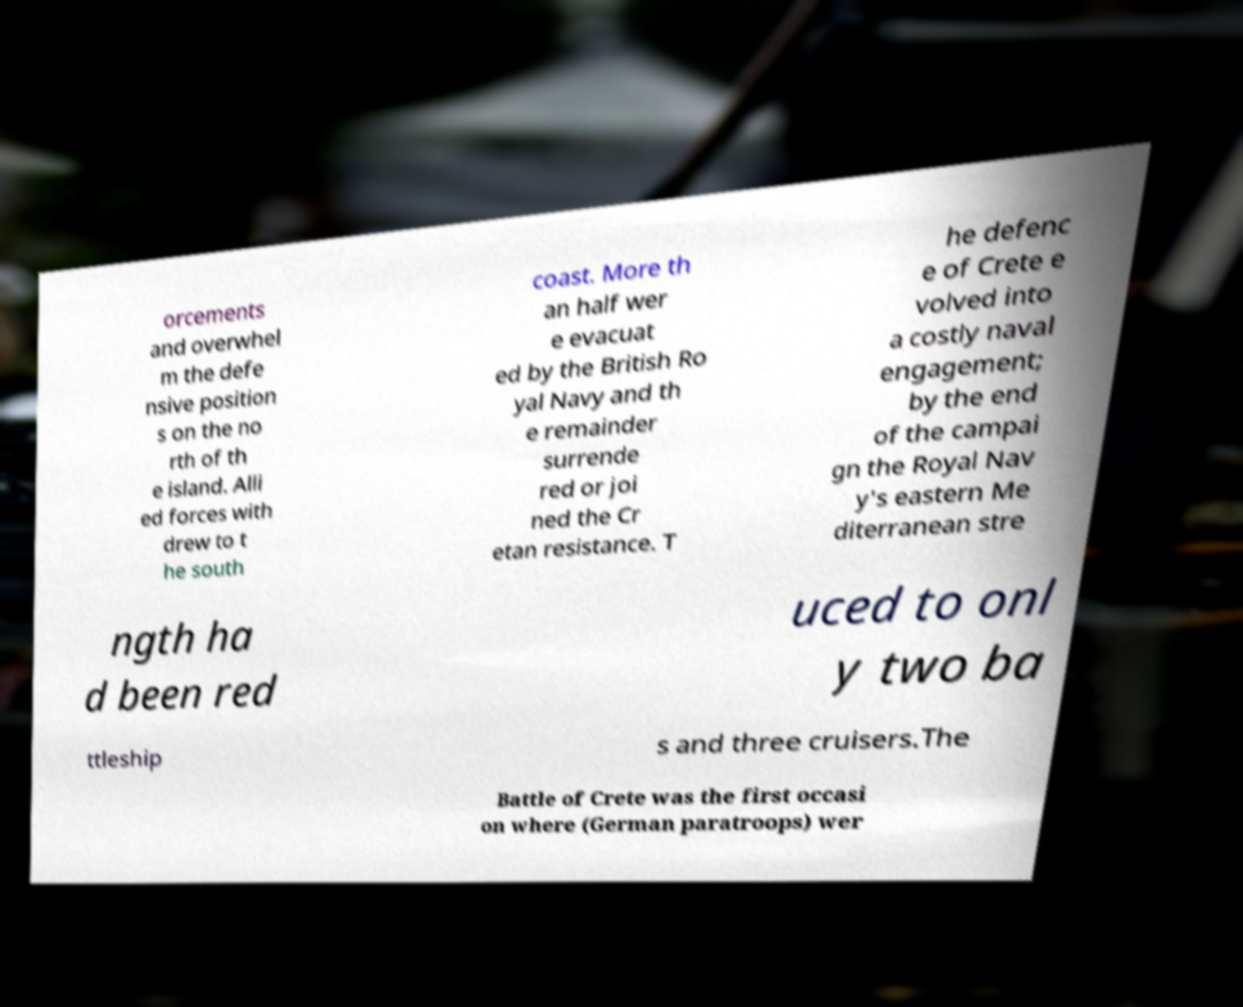What messages or text are displayed in this image? I need them in a readable, typed format. orcements and overwhel m the defe nsive position s on the no rth of th e island. Alli ed forces with drew to t he south coast. More th an half wer e evacuat ed by the British Ro yal Navy and th e remainder surrende red or joi ned the Cr etan resistance. T he defenc e of Crete e volved into a costly naval engagement; by the end of the campai gn the Royal Nav y's eastern Me diterranean stre ngth ha d been red uced to onl y two ba ttleship s and three cruisers.The Battle of Crete was the first occasi on where (German paratroops) wer 